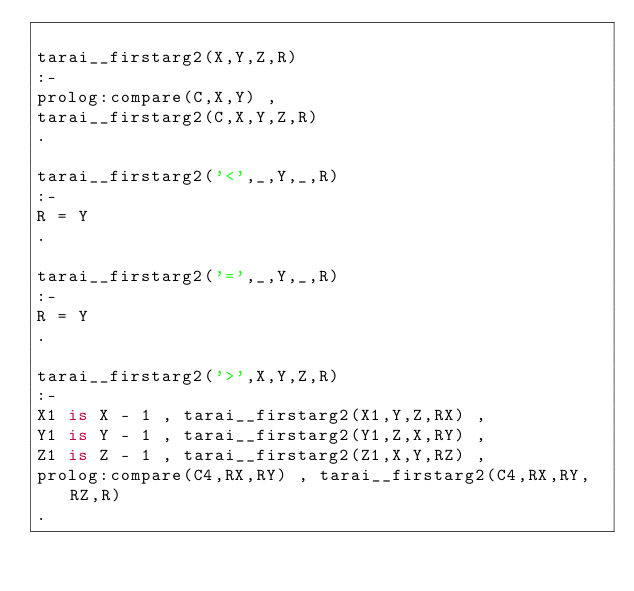<code> <loc_0><loc_0><loc_500><loc_500><_Prolog_>
tarai__firstarg2(X,Y,Z,R)
:-
prolog:compare(C,X,Y) ,
tarai__firstarg2(C,X,Y,Z,R)
.

tarai__firstarg2('<',_,Y,_,R)
:-
R = Y
.

tarai__firstarg2('=',_,Y,_,R)
:-
R = Y
.

tarai__firstarg2('>',X,Y,Z,R)
:-
X1 is X - 1 , tarai__firstarg2(X1,Y,Z,RX) ,
Y1 is Y - 1 , tarai__firstarg2(Y1,Z,X,RY) ,
Z1 is Z - 1 , tarai__firstarg2(Z1,X,Y,RZ) ,
prolog:compare(C4,RX,RY) , tarai__firstarg2(C4,RX,RY,RZ,R)
.

</code> 